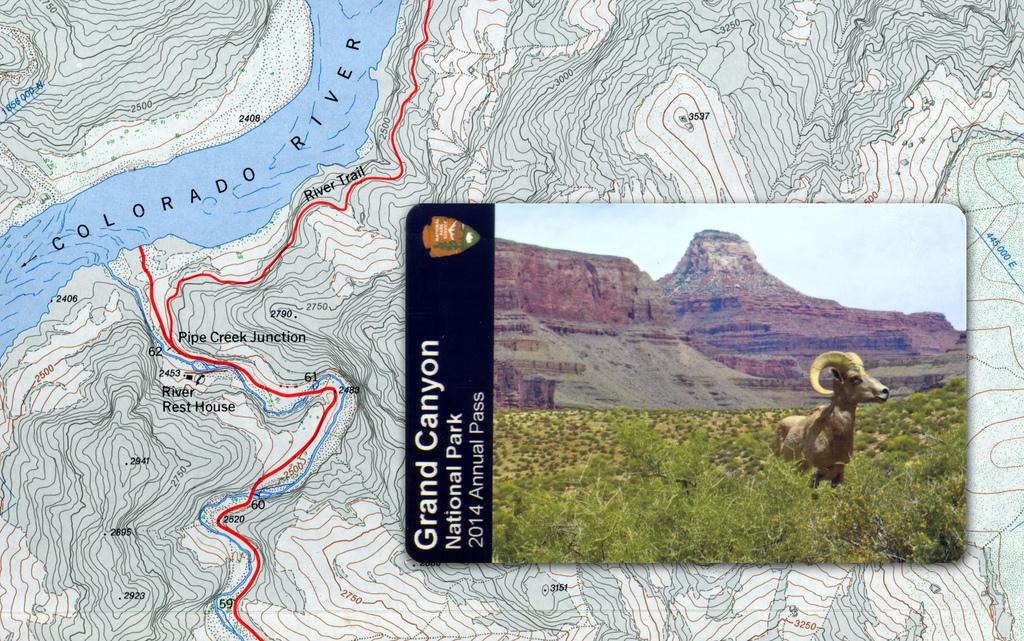What is the main subject of the image? The main subject of the image is a map. What can be seen on the map? There is a landmark of a forest in the image. What type of animal is present in the forest landmark? There is a deer in the forest landmark. What type of cake is being served at the event in the image? There is no event or cake present in the image; it features a map with a forest landmark and a deer. 